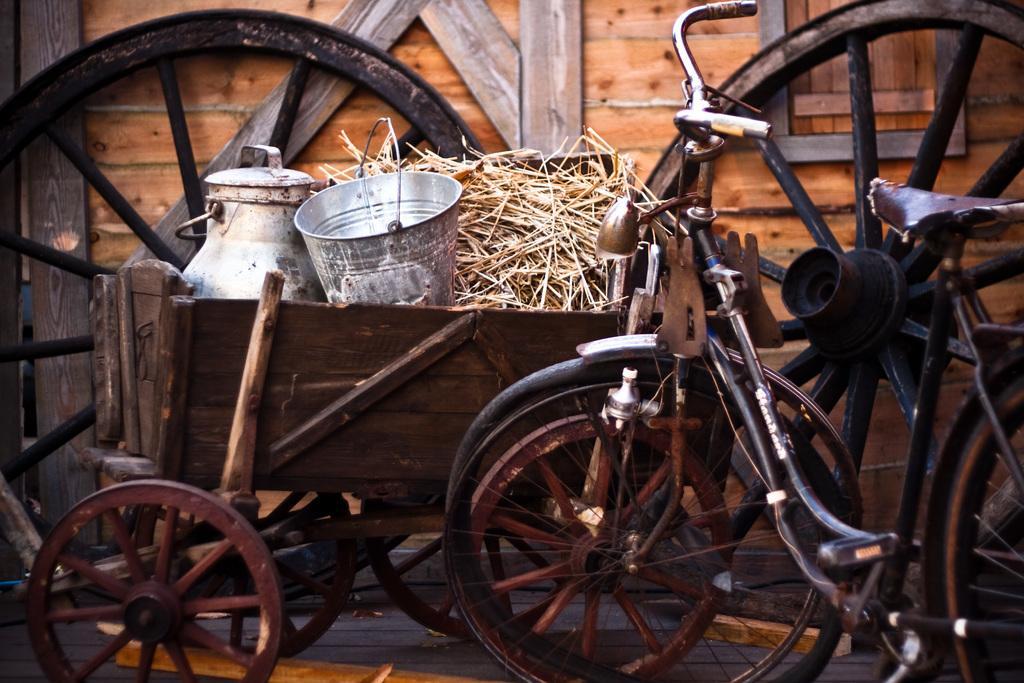Can you describe this image briefly? In this image I can see few bicycle, in front I can see two cans and dried grass. Background I can see the wooden wall. 